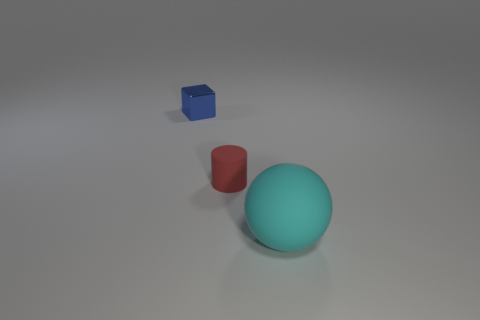Add 2 big yellow metallic blocks. How many objects exist? 5 Subtract all cubes. How many objects are left? 2 Add 1 tiny metal cubes. How many tiny metal cubes exist? 2 Subtract 0 brown cubes. How many objects are left? 3 Subtract all small brown spheres. Subtract all rubber things. How many objects are left? 1 Add 1 red matte cylinders. How many red matte cylinders are left? 2 